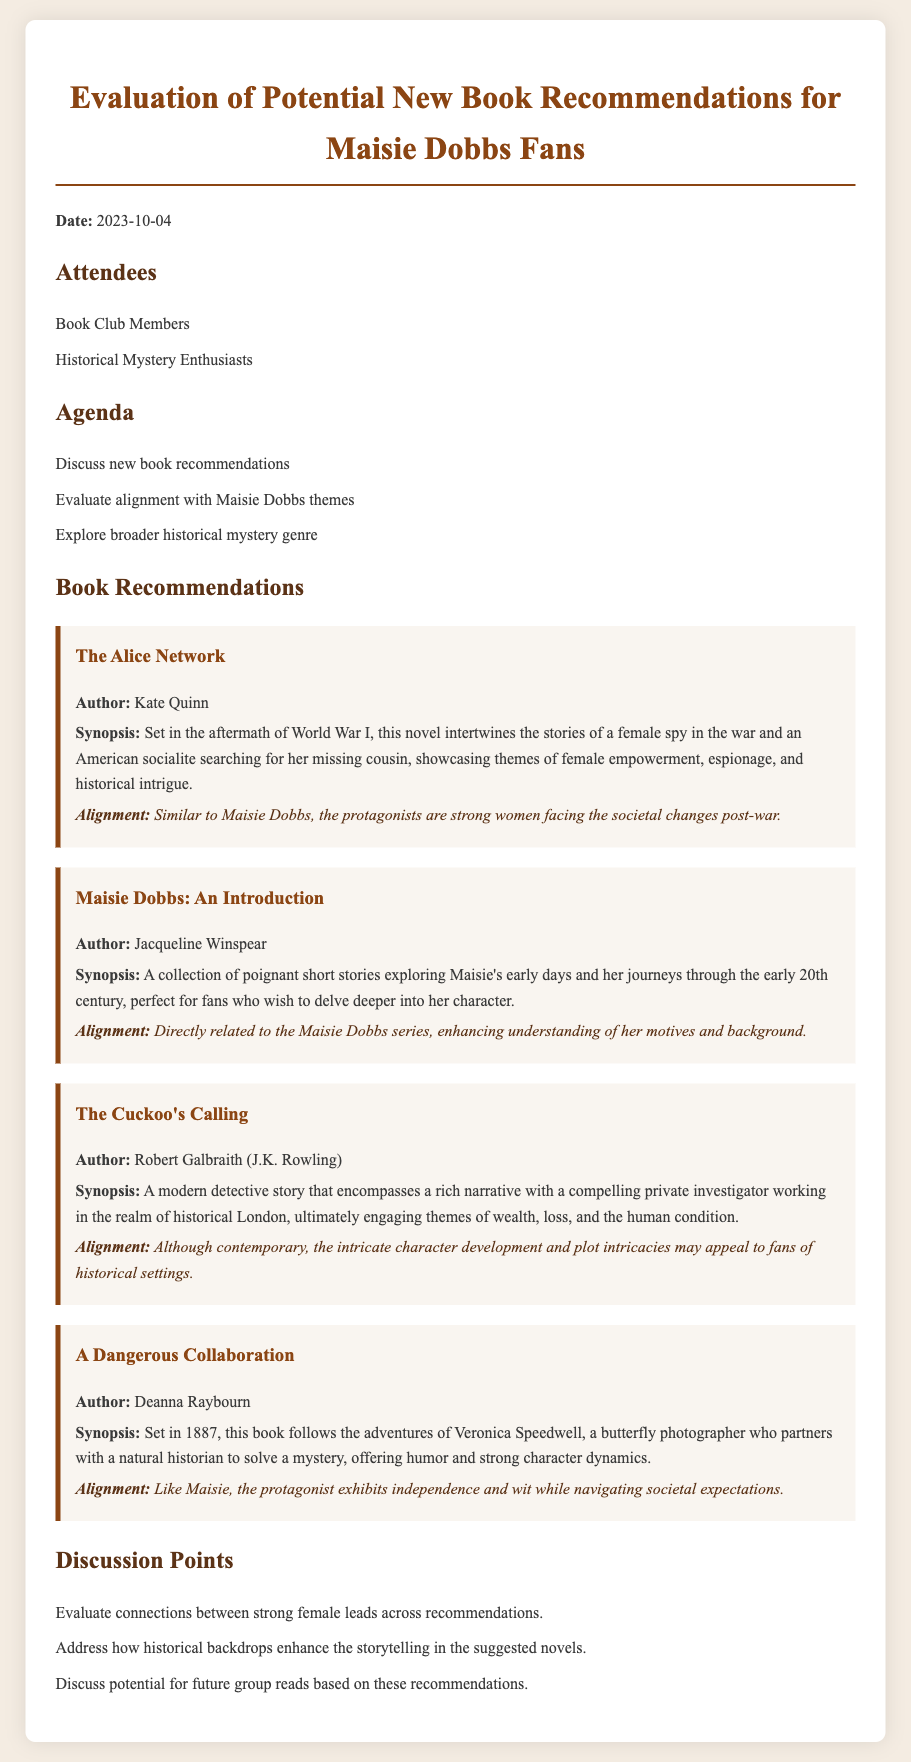what is the date of the meeting? The date of the meeting is explicitly stated in the document.
Answer: 2023-10-04 who wrote "The Alice Network"? The author of "The Alice Network" is specified in the recommendations section.
Answer: Kate Quinn how many books are recommended in the document? The document lists four distinct book recommendations under the "Book Recommendations" section.
Answer: 4 what theme is highlighted in "A Dangerous Collaboration"? The document mentions that the protagonist in "A Dangerous Collaboration" exhibits a specific quality that connects to the themes discussed.
Answer: Independence and wit which book provides an introduction to Maisie's character? The document indicates that a specific book collects stories focusing on Maisie's character and early days.
Answer: Maisie Dobbs: An Introduction what type of gathering is this document associated with? The document clearly indicates the nature of the meeting, which involves members of a specific group.
Answer: Book Club Meeting which author is associated with multiple works mentioned in the meeting? The document identifies an author who appears in both the recommended works and is also the creator of the main character in the series.
Answer: Jacqueline Winspear what is one of the discussion points mentioned? The document outlines several discussion points focusing on connections and themes related to the book recommendations.
Answer: Evaluate connections between strong female leads 